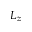<formula> <loc_0><loc_0><loc_500><loc_500>L _ { z }</formula> 